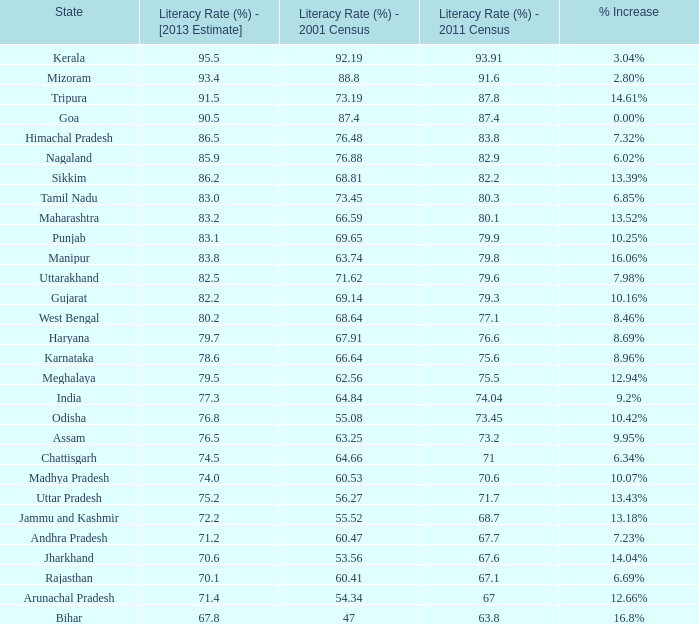What is the average estimated 2013 literacy rate for the states that had a literacy rate of 68.81% in the 2001 census and a literacy rate higher than 79.6% in the 2011 census? 86.2. 